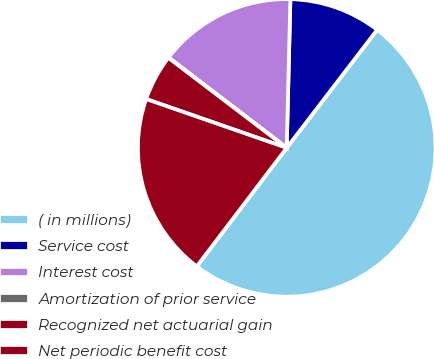Convert chart. <chart><loc_0><loc_0><loc_500><loc_500><pie_chart><fcel>( in millions)<fcel>Service cost<fcel>Interest cost<fcel>Amortization of prior service<fcel>Recognized net actuarial gain<fcel>Net periodic benefit cost<nl><fcel>49.93%<fcel>10.01%<fcel>15.0%<fcel>0.04%<fcel>5.03%<fcel>19.99%<nl></chart> 